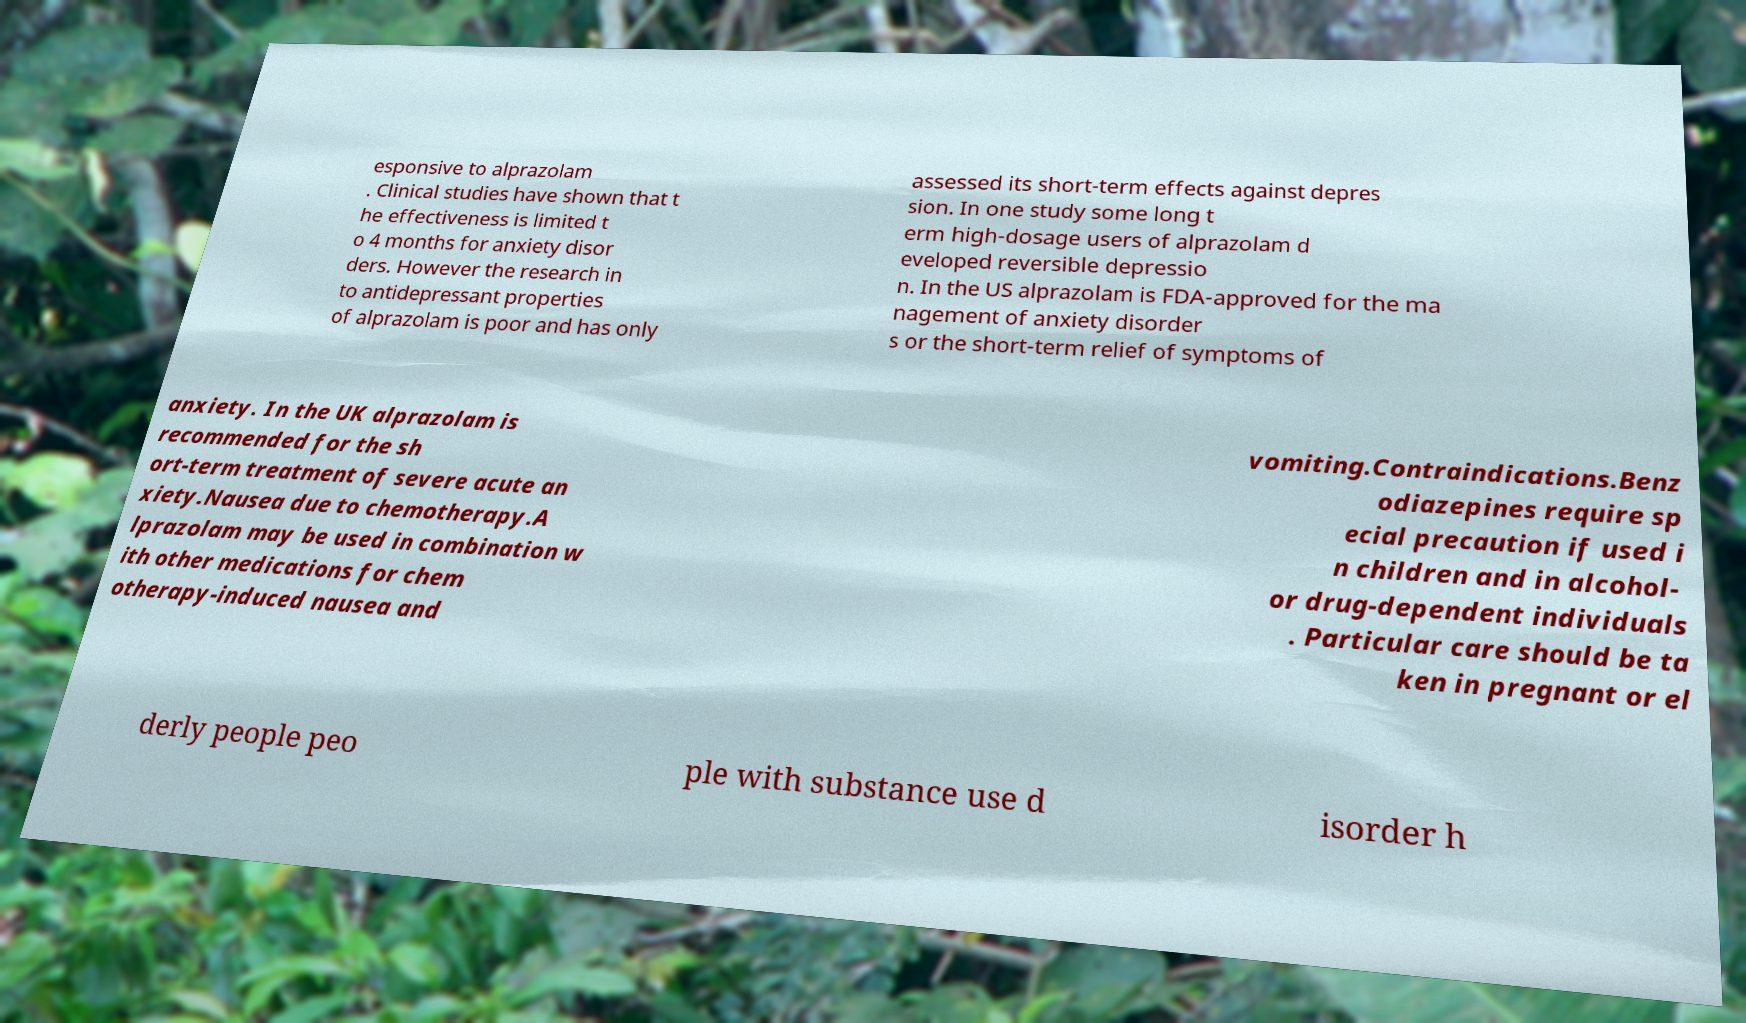Can you accurately transcribe the text from the provided image for me? esponsive to alprazolam . Clinical studies have shown that t he effectiveness is limited t o 4 months for anxiety disor ders. However the research in to antidepressant properties of alprazolam is poor and has only assessed its short-term effects against depres sion. In one study some long t erm high-dosage users of alprazolam d eveloped reversible depressio n. In the US alprazolam is FDA-approved for the ma nagement of anxiety disorder s or the short-term relief of symptoms of anxiety. In the UK alprazolam is recommended for the sh ort-term treatment of severe acute an xiety.Nausea due to chemotherapy.A lprazolam may be used in combination w ith other medications for chem otherapy-induced nausea and vomiting.Contraindications.Benz odiazepines require sp ecial precaution if used i n children and in alcohol- or drug-dependent individuals . Particular care should be ta ken in pregnant or el derly people peo ple with substance use d isorder h 